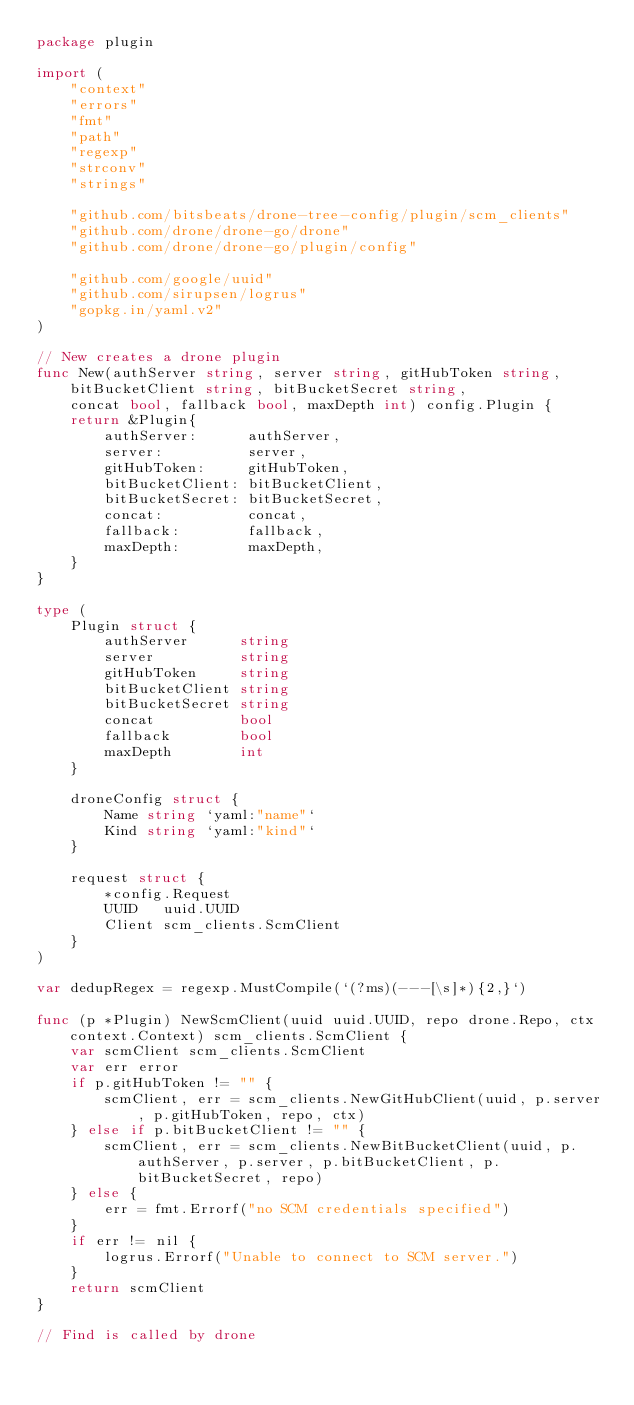<code> <loc_0><loc_0><loc_500><loc_500><_Go_>package plugin

import (
	"context"
	"errors"
	"fmt"
	"path"
	"regexp"
	"strconv"
	"strings"

	"github.com/bitsbeats/drone-tree-config/plugin/scm_clients"
	"github.com/drone/drone-go/drone"
	"github.com/drone/drone-go/plugin/config"

	"github.com/google/uuid"
	"github.com/sirupsen/logrus"
	"gopkg.in/yaml.v2"
)

// New creates a drone plugin
func New(authServer string, server string, gitHubToken string, bitBucketClient string, bitBucketSecret string,
	concat bool, fallback bool, maxDepth int) config.Plugin {
	return &Plugin{
		authServer:      authServer,
		server:          server,
		gitHubToken:     gitHubToken,
		bitBucketClient: bitBucketClient,
		bitBucketSecret: bitBucketSecret,
		concat:          concat,
		fallback:        fallback,
		maxDepth:        maxDepth,
	}
}

type (
	Plugin struct {
		authServer      string
		server          string
		gitHubToken     string
		bitBucketClient string
		bitBucketSecret string
		concat          bool
		fallback        bool
		maxDepth        int
	}

	droneConfig struct {
		Name string `yaml:"name"`
		Kind string `yaml:"kind"`
	}

	request struct {
		*config.Request
		UUID   uuid.UUID
		Client scm_clients.ScmClient
	}
)

var dedupRegex = regexp.MustCompile(`(?ms)(---[\s]*){2,}`)

func (p *Plugin) NewScmClient(uuid uuid.UUID, repo drone.Repo, ctx context.Context) scm_clients.ScmClient {
	var scmClient scm_clients.ScmClient
	var err error
	if p.gitHubToken != "" {
		scmClient, err = scm_clients.NewGitHubClient(uuid, p.server, p.gitHubToken, repo, ctx)
	} else if p.bitBucketClient != "" {
		scmClient, err = scm_clients.NewBitBucketClient(uuid, p.authServer, p.server, p.bitBucketClient, p.bitBucketSecret, repo)
	} else {
		err = fmt.Errorf("no SCM credentials specified")
	}
	if err != nil {
		logrus.Errorf("Unable to connect to SCM server.")
	}
	return scmClient
}

// Find is called by drone</code> 